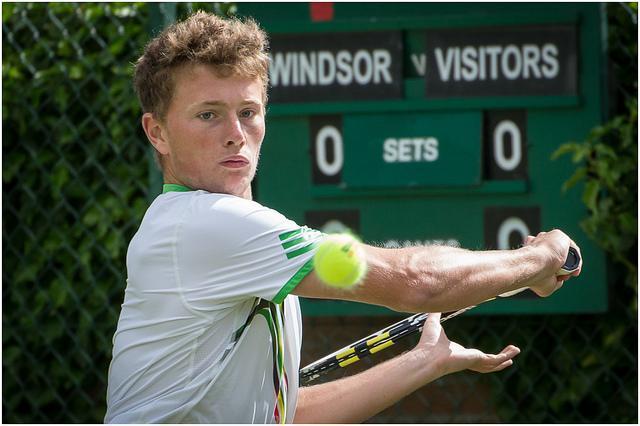How many flowers in the vase are yellow?
Give a very brief answer. 0. 